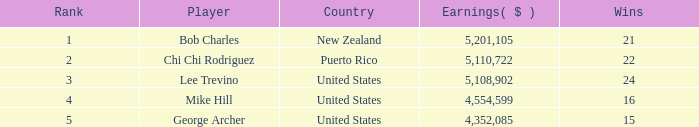On average, how many wins have a rank lower than 1? None. 